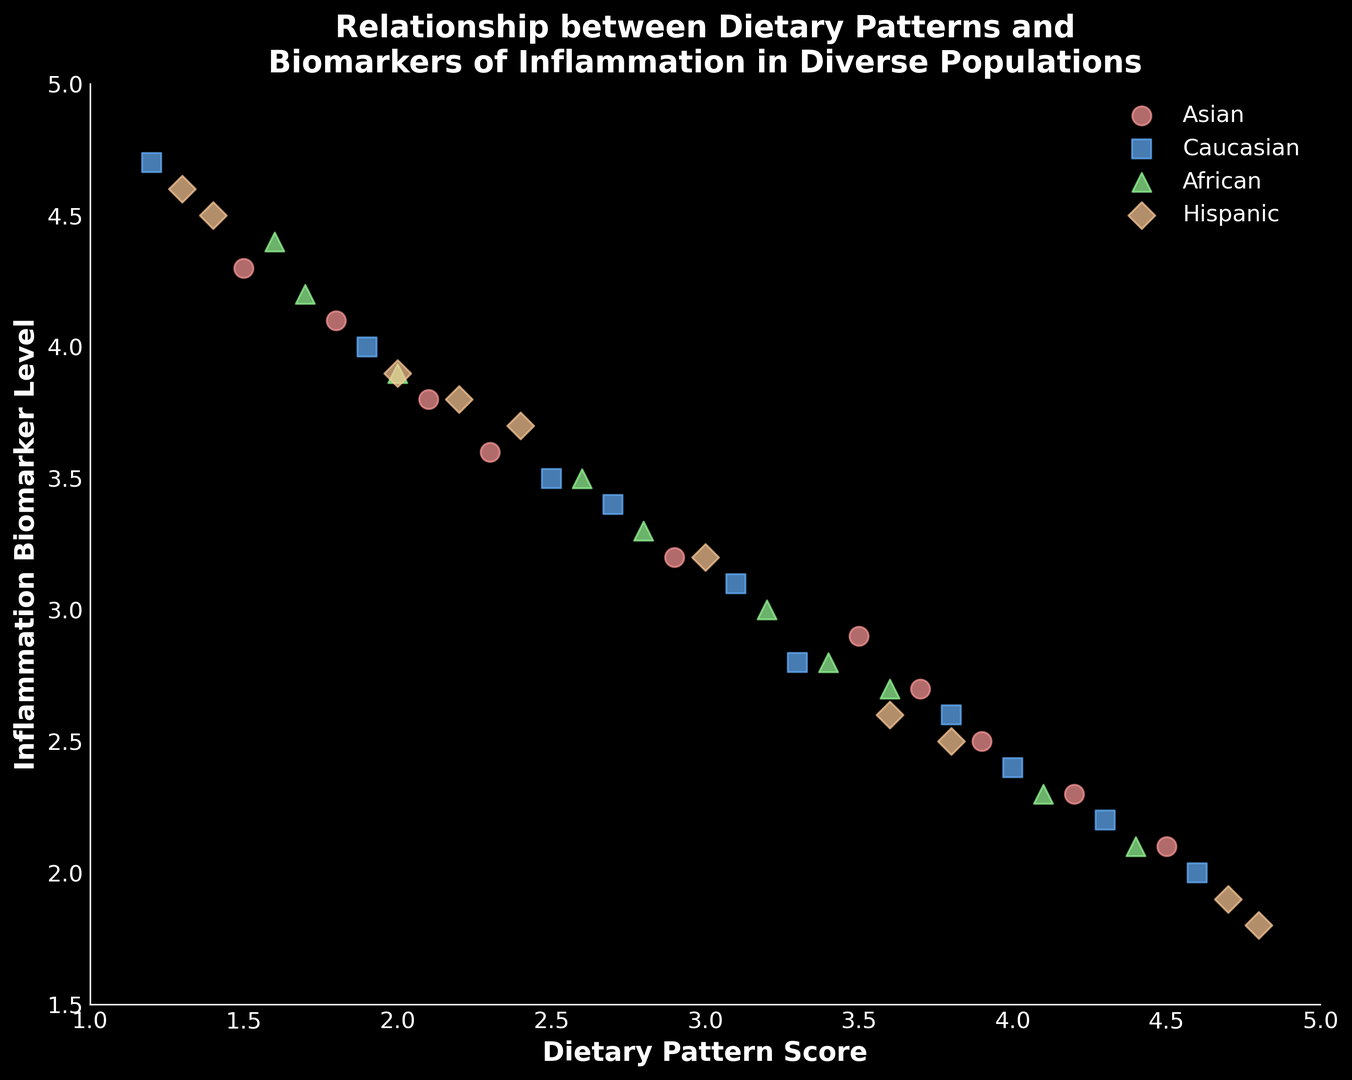What is the range of dietary pattern scores for the Hispanic group? To find the range, look for the lowest and highest dietary pattern scores within the Hispanic group. The data indicates the lowest score is 1.3 and the highest score is 4.8
Answer: 1.3 to 4.8 Which population group has the highest inflammation biomarker level? To determine the highest inflammation biomarker level, visually scan for the highest point on the y-axis. The highest value is 4.7, which belongs to the Caucasian group.
Answer: Caucasian What is the average inflammation biomarker level for the African group? Locate all inflammation biomarker levels for the African group: 4.4, 3.3, 2.7, 2.1, 3.9, 3.0, 2.3, 4.2, 3.5, and 2.8. Sum these values (32.2) and divide by the number of data points (10). The average = 32.2 / 10 = 3.22
Answer: 3.22 How does the dietary pattern score of Asians compare to that of the other groups? Compare the overall distribution of scores for Asians (range: 1.5 to 4.5) with those of Caucasians (1.2 to 4.6), Africans (1.6 to 4.4), and Hispanics (1.3 to 4.8). The range is quite similar across groups, showing no significant difference in dietary pattern scores.
Answer: No significant difference Which group shows the largest decrease in inflammation biomarker level with increasing dietary pattern scores? Identify the trend lines or clusters for each group. The Hispanic group shows noticeable decreases in inflammation biomarker levels as dietary pattern scores increase, indicating they have the largest decrease.
Answer: Hispanic For the Caucasian group, what is the difference between the highest and lowest inflammation biomarker levels? Locate the highest (4.7) and lowest (2.0) biomarker levels for the Caucasians. The range is 4.7 - 2.0 = 2.7
Answer: 2.7 Are there outliers in inflammation biomarker levels for any of the groups? Visually inspect the scatter plot for any points that lie distinctly away from the general distribution. No significant outliers are visible for any group, indicating a consistent trend across all data points.
Answer: No outliers What is the median dietary pattern score for the Asian group? First, sort the dietary pattern scores for the Asian group: 1.5, 1.8, 2.1, 2.3, 2.9, 3.5, 3.7, 3.9, 4.2, 4.5. The median is the middle value in this even set. Average the two middle values: (2.9 + 3.5)/2 = 3.2
Answer: 3.2 